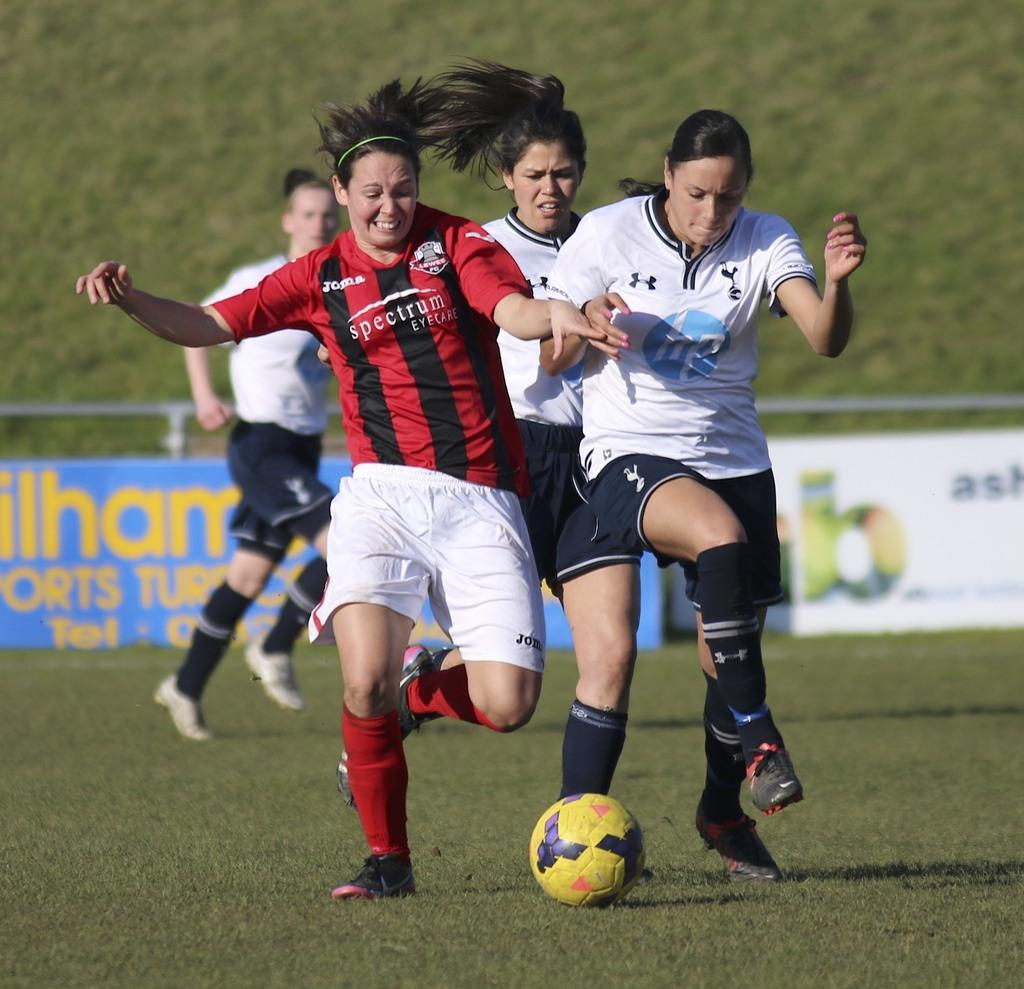How many people are in the image? There is a group of people in the image. What are some people doing in the image? Some people are playing a game in the ground. What object is being used in the game? There is a ball in front of the people playing the game. What can be seen in the background of the image? There are hoardings and metal rods in the background of the image. What type of holiday is being celebrated in the image? There is no indication of a holiday being celebrated in the image. What kind of camera is being used to capture the image? The question assumes that the image is a photograph, but we cannot determine the type of camera used based on the image itself. 